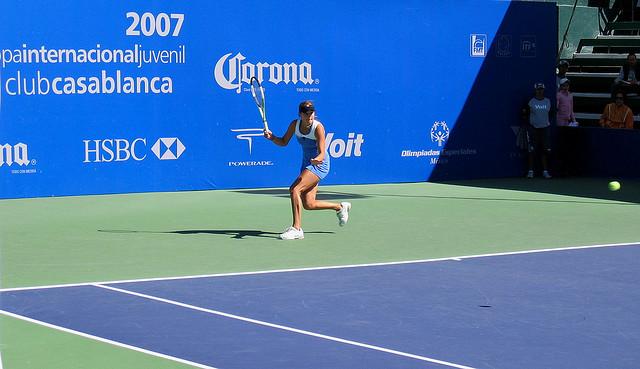What sport is this?
Quick response, please. Tennis. What is the number shown in the image?
Answer briefly. 2007. What beer is a sponsor at this event?
Give a very brief answer. Corona. Is this a sunny day?
Short answer required. Yes. Which beer is being advertised on the wall in the back?
Give a very brief answer. Corona. 